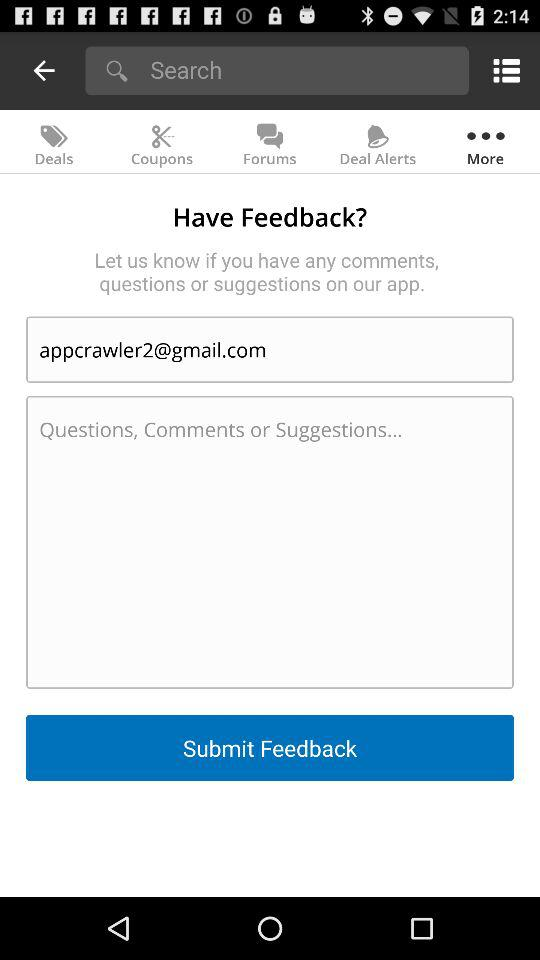What is the name of the application?
When the provided information is insufficient, respond with <no answer>. <no answer> 